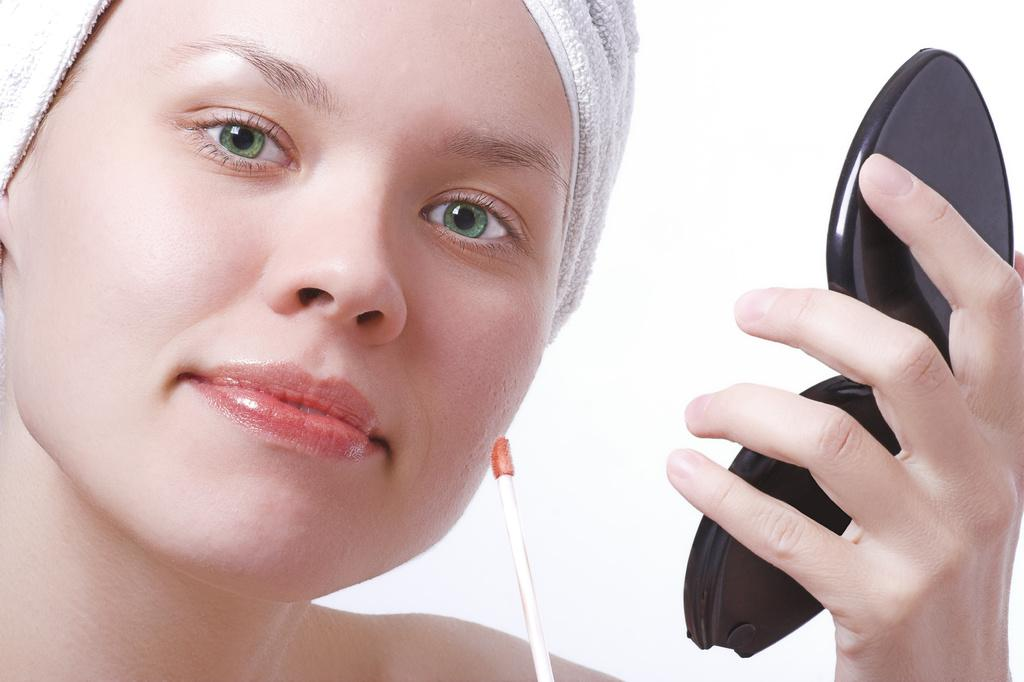Who is the main subject in the image? There is a woman in the image. What is the woman wearing on her head? The woman is wearing a cloth on her head. What is the woman holding in her hand? The woman is holding a black-colored object in her hand. What is the color of the background in the image? The background of the image is white. How many sticks can be seen in the woman's hand in the image? There are no sticks visible in the woman's hand in the image. What type of cakes is the woman holding in the image? There is no cake present in the image; the woman is holding a black-colored object. 